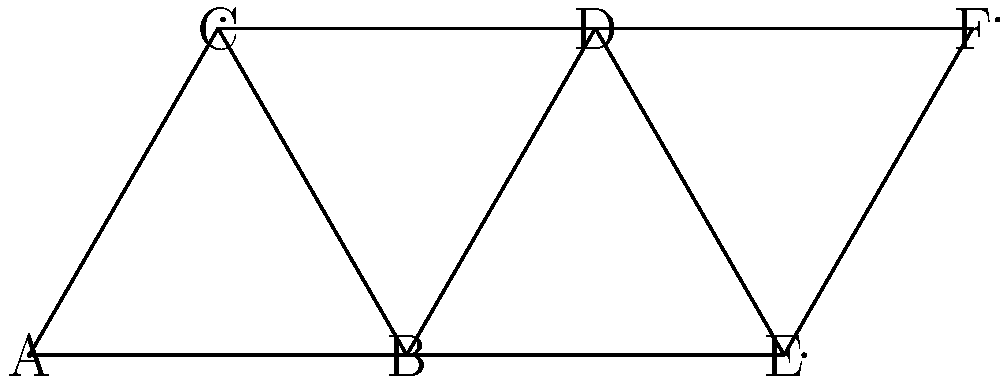You're designing a new kennel layout for your rare breed dogs. The graph represents possible connections between kennels, where nodes are kennels and edges are pathways. What is the minimum number of pathways (edges) you need to remove to ensure no circular routes exist in the layout while still keeping all kennels connected? To solve this problem, we need to find the minimum number of edges to remove to create a spanning tree of the graph. A spanning tree is a subgraph that connects all nodes without any cycles. Here's the step-by-step approach:

1. Count the total number of nodes (kennels) and edges (pathways):
   Nodes: 6 (A, B, C, D, E, F)
   Edges: 8

2. Recall that in a tree, the number of edges is always one less than the number of nodes. So, for a spanning tree with 6 nodes, we need 5 edges.

3. Calculate the number of edges to remove:
   Edges to remove = Total edges - Edges in spanning tree
   Edges to remove = 8 - 5 = 3

4. Verify: After removing 3 edges, we'll have 5 edges connecting 6 nodes, which forms a tree structure without cycles while keeping all kennels connected.

Therefore, the minimum number of pathways to remove is 3.
Answer: 3 